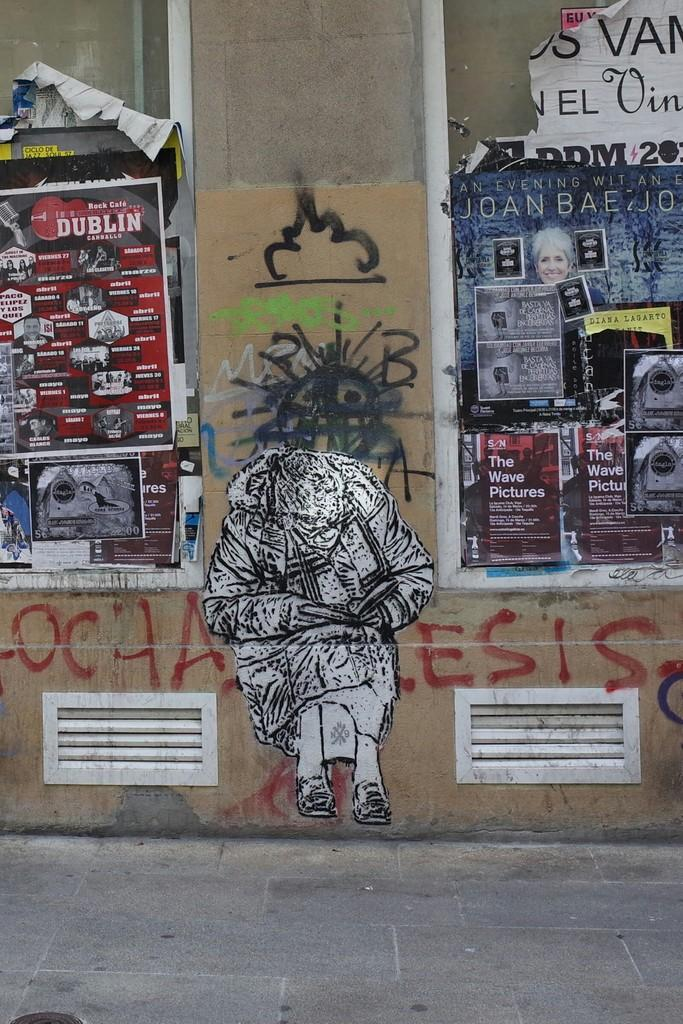What is present on the wall in the image? There are posters and graffiti on the wall in the image. Can you describe the posters on the wall? Unfortunately, the details of the posters cannot be determined from the image. What type of artwork is visible on the wall? The graffiti on the wall is a form of artwork visible in the image. How many worms can be seen crawling on the wall in the image? There are no worms present in the image; it only features posters and graffiti on the wall. What color are the ants that are visible on the wall in the image? There are no ants present in the image; it only features posters and graffiti on the wall. 